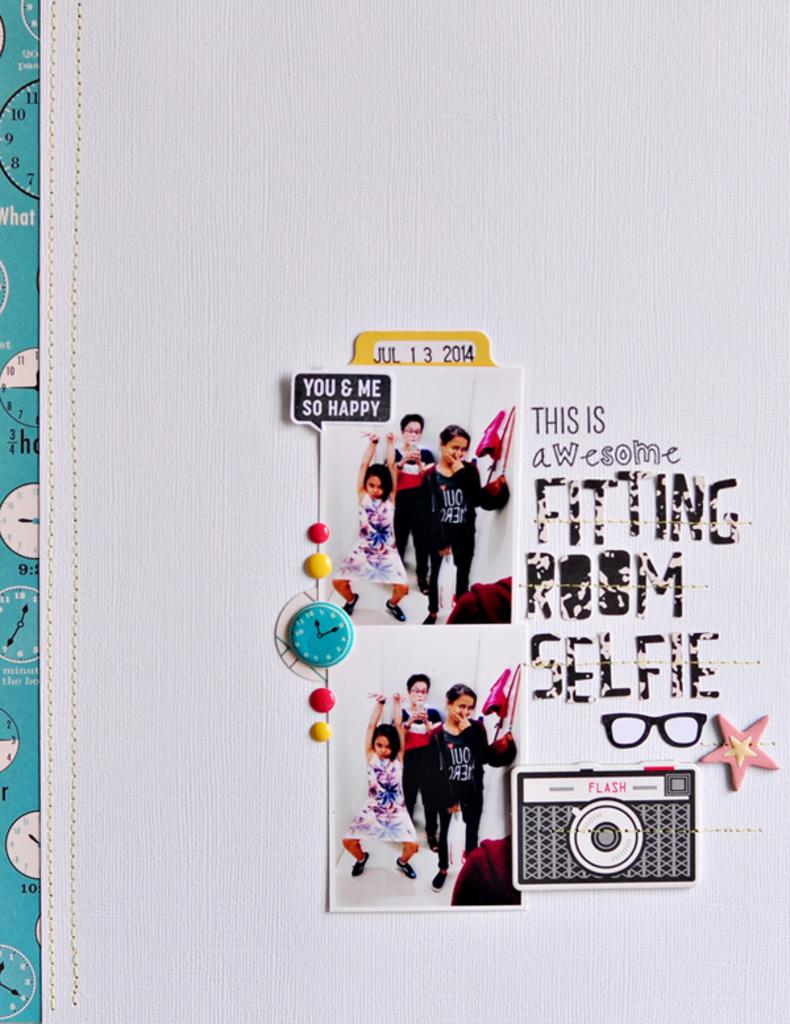What does it say under 'fitting room'?
Make the answer very short. Selfie. 